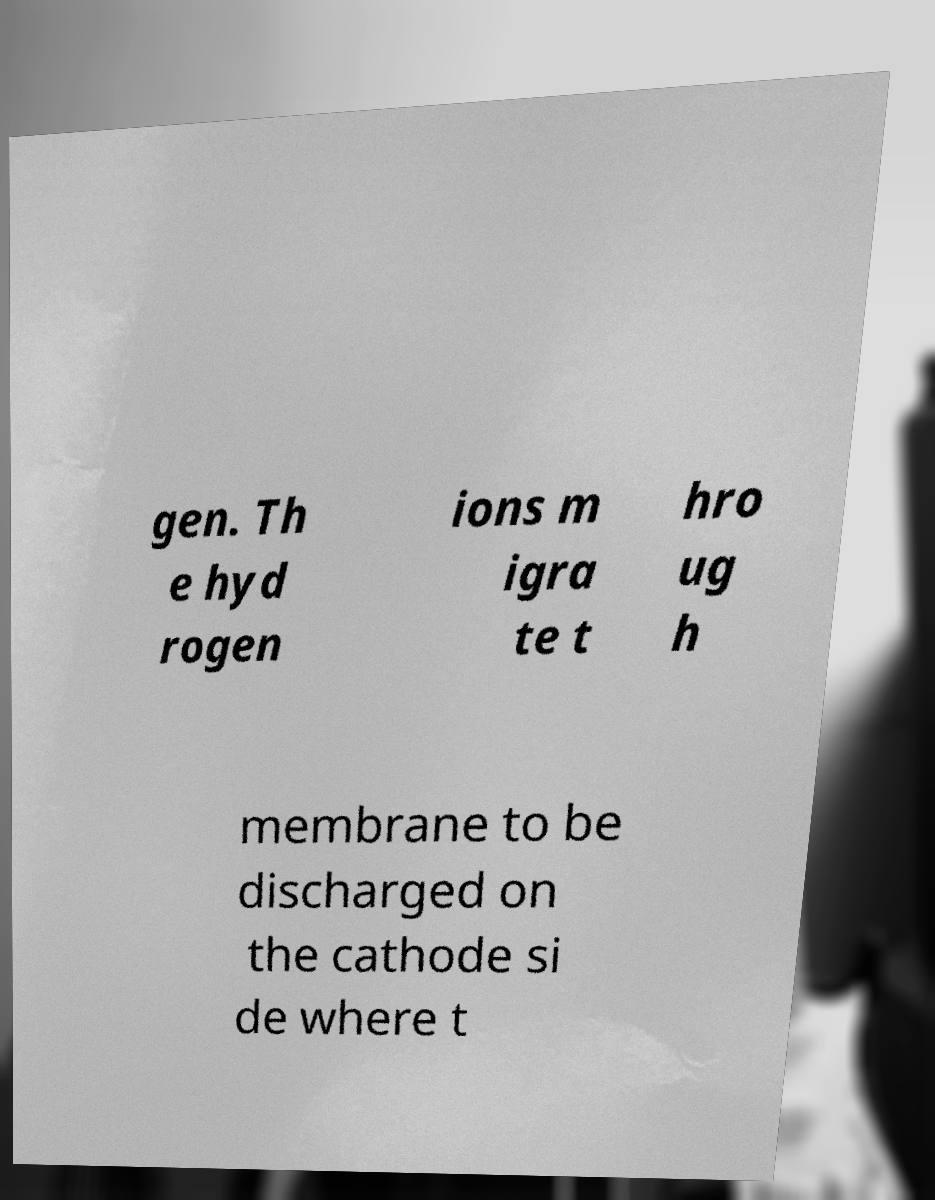Please read and relay the text visible in this image. What does it say? gen. Th e hyd rogen ions m igra te t hro ug h membrane to be discharged on the cathode si de where t 